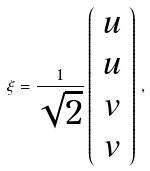<formula> <loc_0><loc_0><loc_500><loc_500>\xi = \frac { 1 } { \sqrt { 2 } } \left ( \begin{array} { c } u \\ u \\ v \\ v \end{array} \right ) \, ,</formula> 